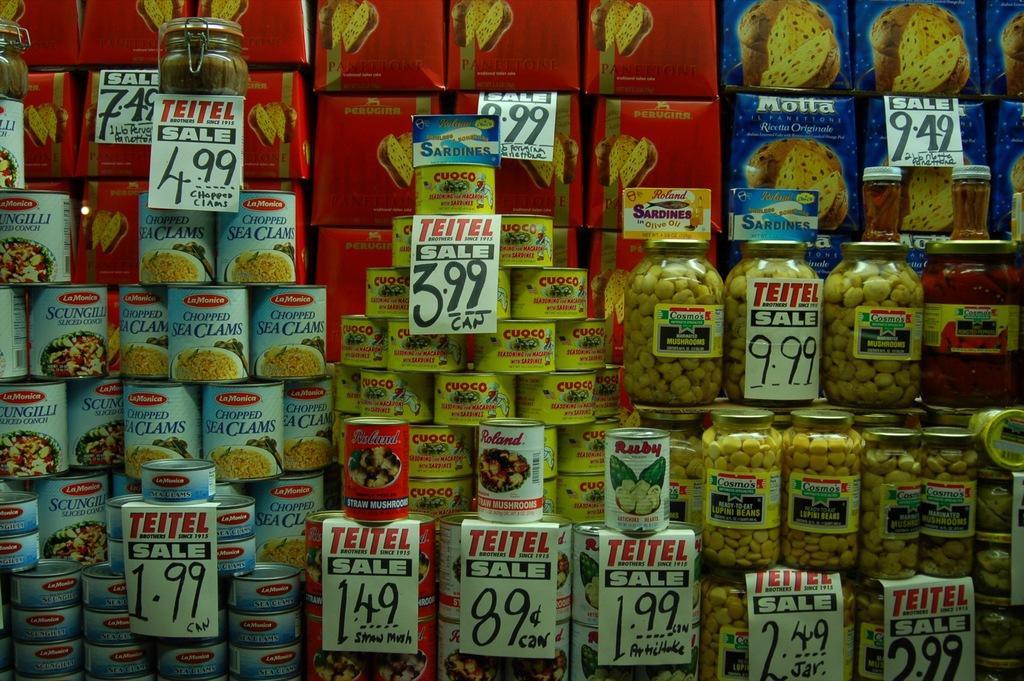How much is a can of chopped sea clams?
Your answer should be very brief. 1.99. What is the lowest priced item?
Offer a terse response. 89. 